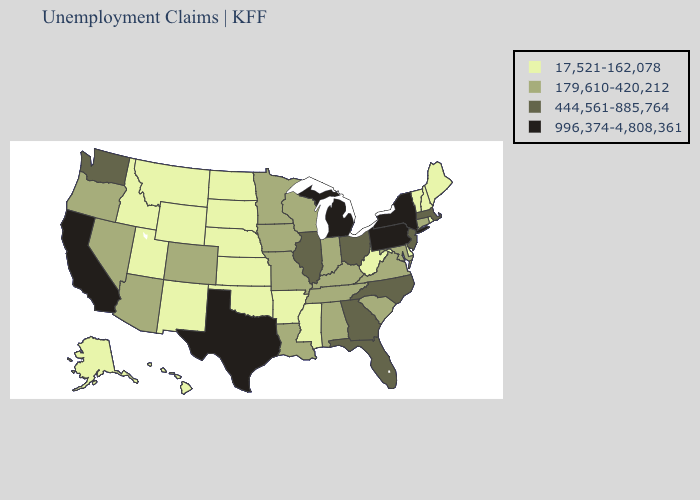What is the lowest value in states that border Utah?
Write a very short answer. 17,521-162,078. What is the highest value in states that border Tennessee?
Answer briefly. 444,561-885,764. Name the states that have a value in the range 17,521-162,078?
Write a very short answer. Alaska, Arkansas, Delaware, Hawaii, Idaho, Kansas, Maine, Mississippi, Montana, Nebraska, New Hampshire, New Mexico, North Dakota, Oklahoma, Rhode Island, South Dakota, Utah, Vermont, West Virginia, Wyoming. Does North Carolina have a lower value than Oklahoma?
Concise answer only. No. Among the states that border New Mexico , which have the lowest value?
Keep it brief. Oklahoma, Utah. How many symbols are there in the legend?
Write a very short answer. 4. What is the value of New York?
Keep it brief. 996,374-4,808,361. Which states have the highest value in the USA?
Short answer required. California, Michigan, New York, Pennsylvania, Texas. Does Indiana have a lower value than Rhode Island?
Answer briefly. No. What is the lowest value in the USA?
Short answer required. 17,521-162,078. Among the states that border Arkansas , does Oklahoma have the lowest value?
Short answer required. Yes. Among the states that border Missouri , does Illinois have the highest value?
Short answer required. Yes. Is the legend a continuous bar?
Concise answer only. No. What is the lowest value in states that border Minnesota?
Be succinct. 17,521-162,078. Name the states that have a value in the range 17,521-162,078?
Concise answer only. Alaska, Arkansas, Delaware, Hawaii, Idaho, Kansas, Maine, Mississippi, Montana, Nebraska, New Hampshire, New Mexico, North Dakota, Oklahoma, Rhode Island, South Dakota, Utah, Vermont, West Virginia, Wyoming. 